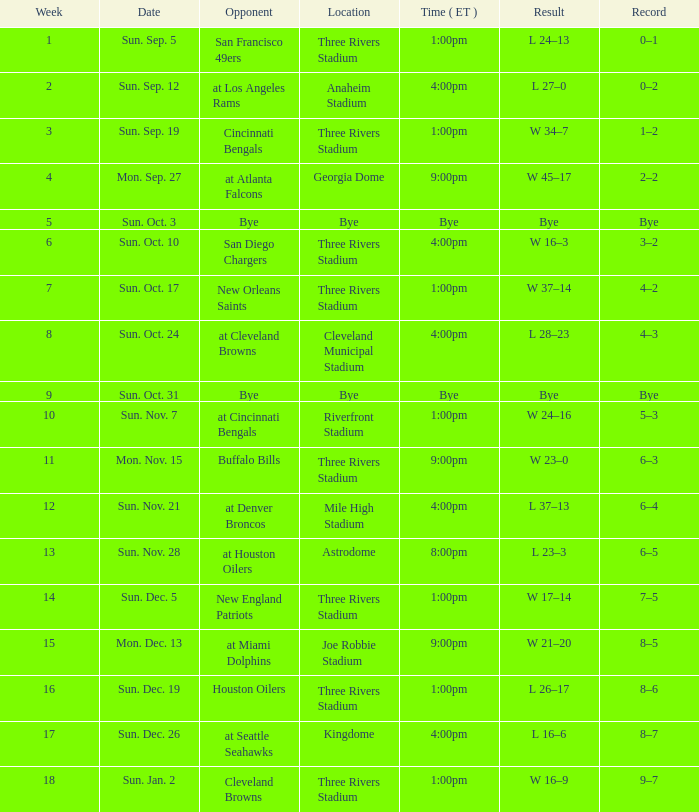What is the first week that has an 8-5 record documented? 15.0. 